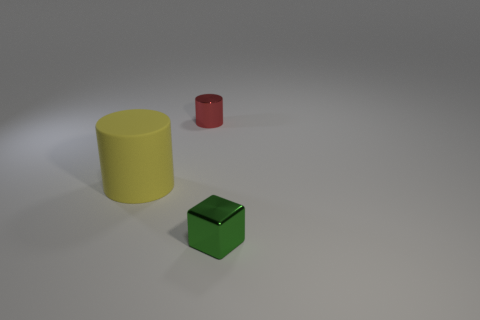Are there any other things that have the same material as the large cylinder?
Your answer should be very brief. No. What is the color of the tiny metallic object that is in front of the cylinder behind the large matte object?
Offer a very short reply. Green. Is there a tiny shiny block of the same color as the rubber object?
Provide a succinct answer. No. How big is the cylinder that is in front of the object behind the cylinder in front of the metallic cylinder?
Give a very brief answer. Large. There is a large yellow matte thing; is it the same shape as the tiny metal object behind the large object?
Provide a short and direct response. Yes. How many other objects are the same size as the matte object?
Provide a succinct answer. 0. There is a thing that is on the left side of the tiny red cylinder; what size is it?
Offer a terse response. Large. What number of small red things are the same material as the tiny green block?
Offer a very short reply. 1. Do the metallic thing that is behind the rubber object and the yellow rubber object have the same shape?
Provide a succinct answer. Yes. What is the shape of the shiny thing in front of the small red shiny thing?
Provide a short and direct response. Cube. 